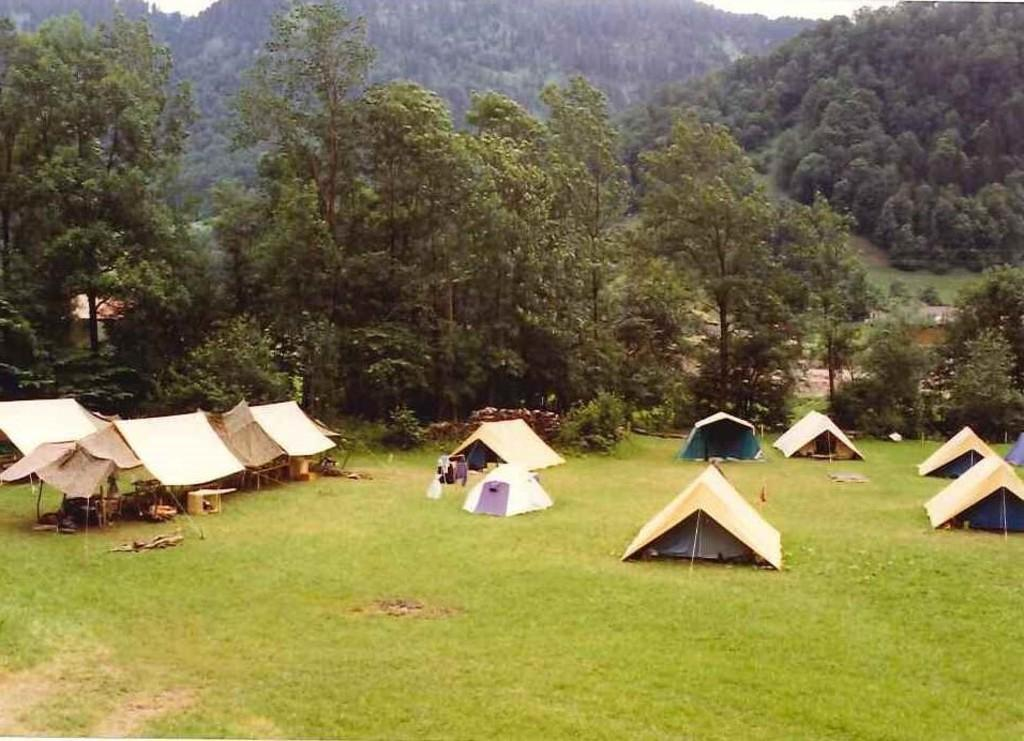What type of structures are set up on the grass surface in the image? There are tents on the grass surface in the image. What can be seen behind the tents in the image? There are many trees behind the tents in the image. What is visible in the distance in the background of the image? There is a mountain visible in the background of the image. What type of crime is being committed in the image? There is no indication of any crime being committed in the image; it features tents on a grass surface with trees and a mountain in the background. How many toes are visible in the image? There are no visible toes in the image. 